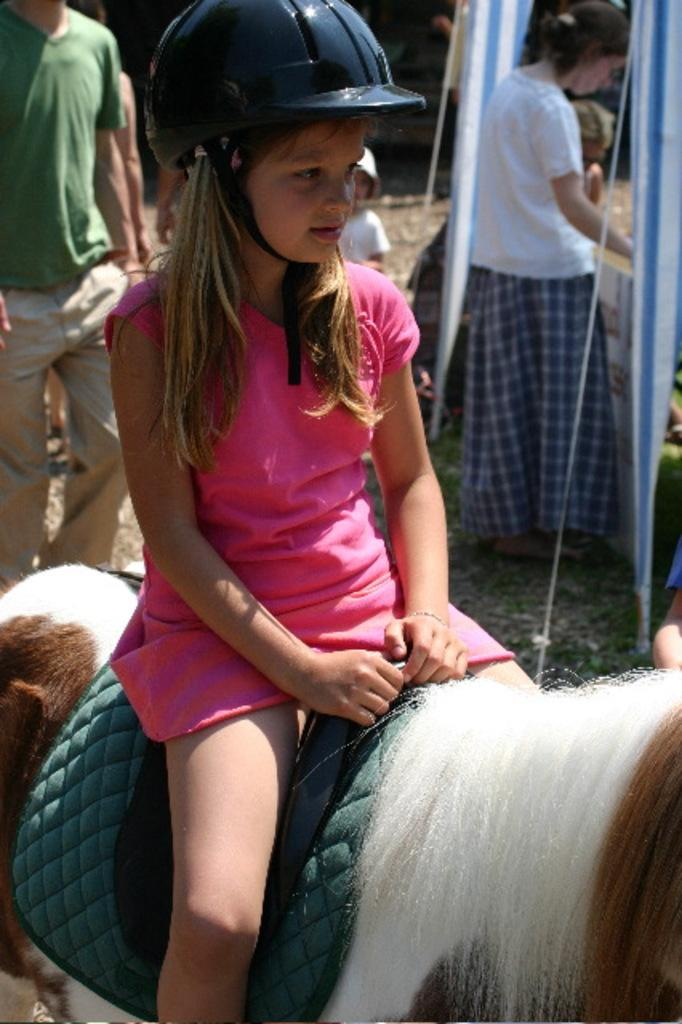What is the person in the image doing? The person is sitting on an animal in the image. What protective gear is the person wearing? The person is wearing a helmet. Can you describe the people in the background of the image? There are people standing in the background of the image. What type of juice is the baby holding in the image? There is no baby or juice present in the image. What is the animal using to rake leaves in the image? The animal is not raking leaves in the image; the person is sitting on it. 